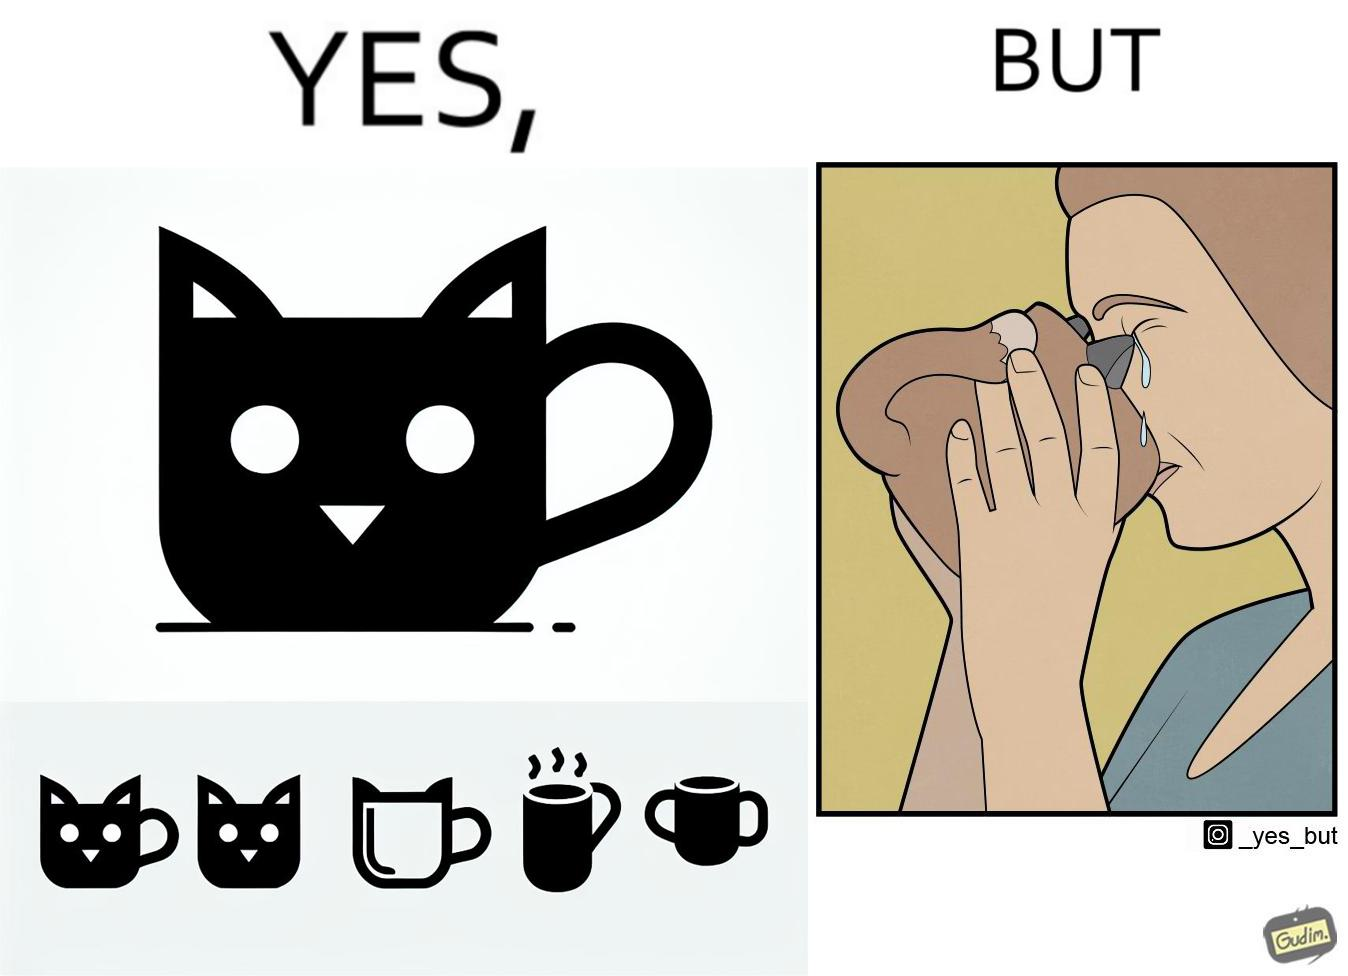Describe the satirical element in this image. The irony in the image is that the mug is supposedly cute and quirky but it is completely impractical as a mug as it will hurt its user. 